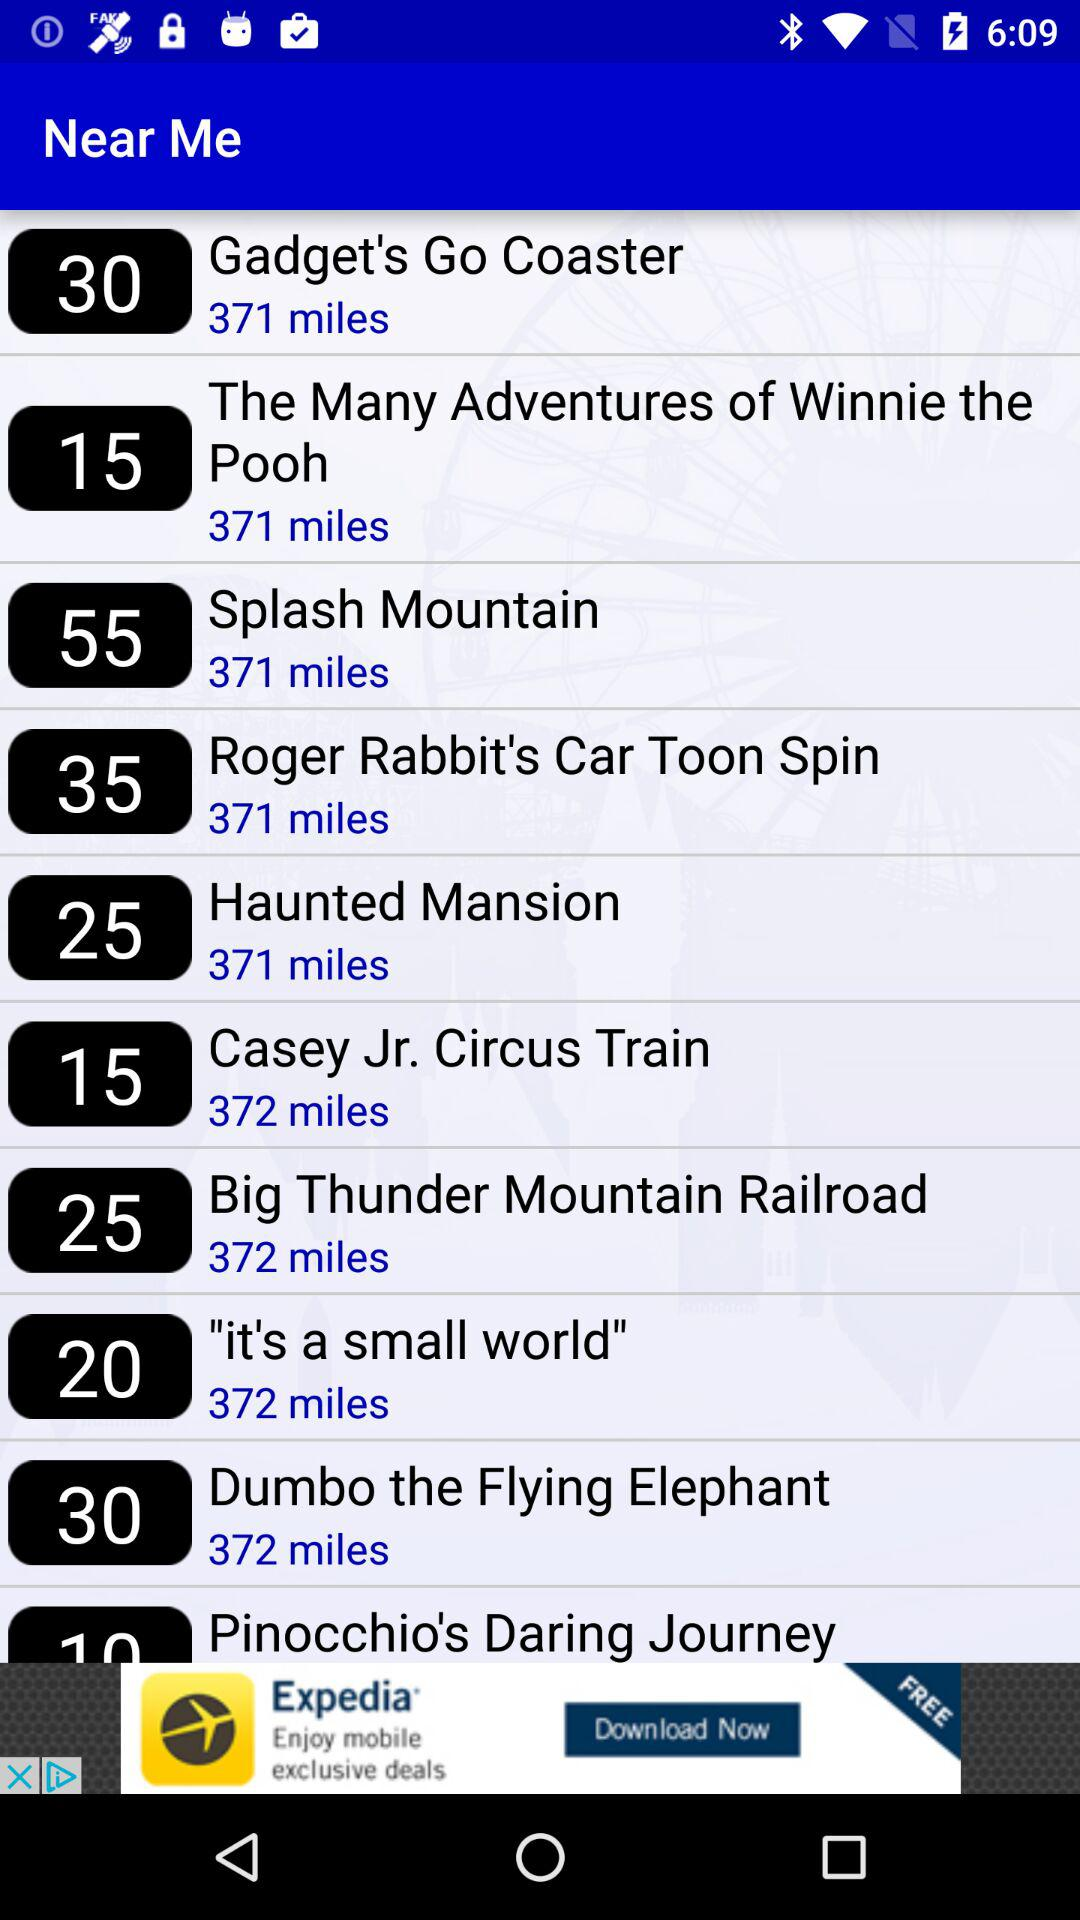How many miles away is the furthest ride?
Answer the question using a single word or phrase. 372 miles 